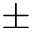Convert formula to latex. <formula><loc_0><loc_0><loc_500><loc_500>\pm</formula> 